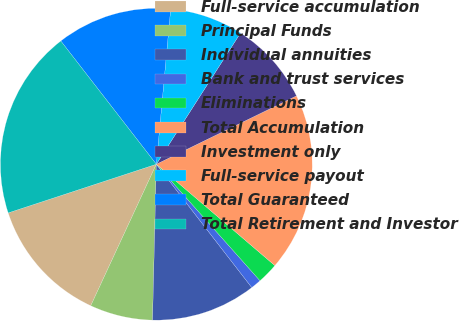Convert chart. <chart><loc_0><loc_0><loc_500><loc_500><pie_chart><fcel>Full-service accumulation<fcel>Principal Funds<fcel>Individual annuities<fcel>Bank and trust services<fcel>Eliminations<fcel>Total Accumulation<fcel>Investment only<fcel>Full-service payout<fcel>Total Guaranteed<fcel>Total Retirement and Investor<nl><fcel>13.04%<fcel>6.52%<fcel>10.87%<fcel>1.09%<fcel>2.17%<fcel>18.48%<fcel>8.7%<fcel>7.61%<fcel>11.96%<fcel>19.56%<nl></chart> 